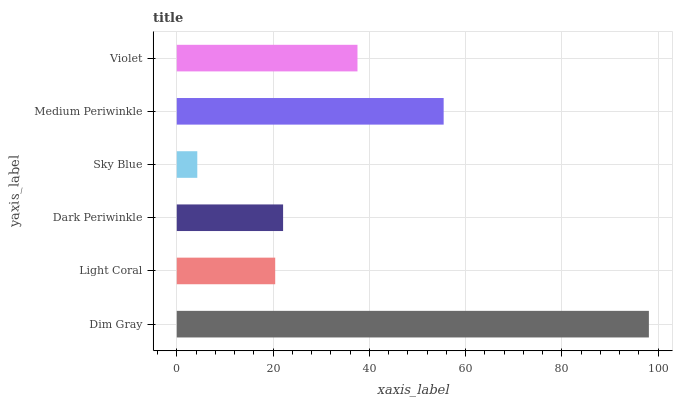Is Sky Blue the minimum?
Answer yes or no. Yes. Is Dim Gray the maximum?
Answer yes or no. Yes. Is Light Coral the minimum?
Answer yes or no. No. Is Light Coral the maximum?
Answer yes or no. No. Is Dim Gray greater than Light Coral?
Answer yes or no. Yes. Is Light Coral less than Dim Gray?
Answer yes or no. Yes. Is Light Coral greater than Dim Gray?
Answer yes or no. No. Is Dim Gray less than Light Coral?
Answer yes or no. No. Is Violet the high median?
Answer yes or no. Yes. Is Dark Periwinkle the low median?
Answer yes or no. Yes. Is Sky Blue the high median?
Answer yes or no. No. Is Medium Periwinkle the low median?
Answer yes or no. No. 